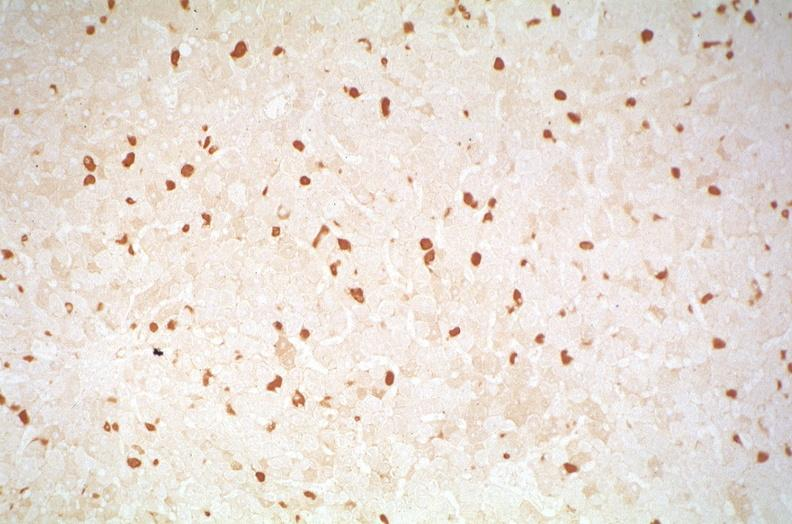s metastatic neuroblastoma present?
Answer the question using a single word or phrase. No 